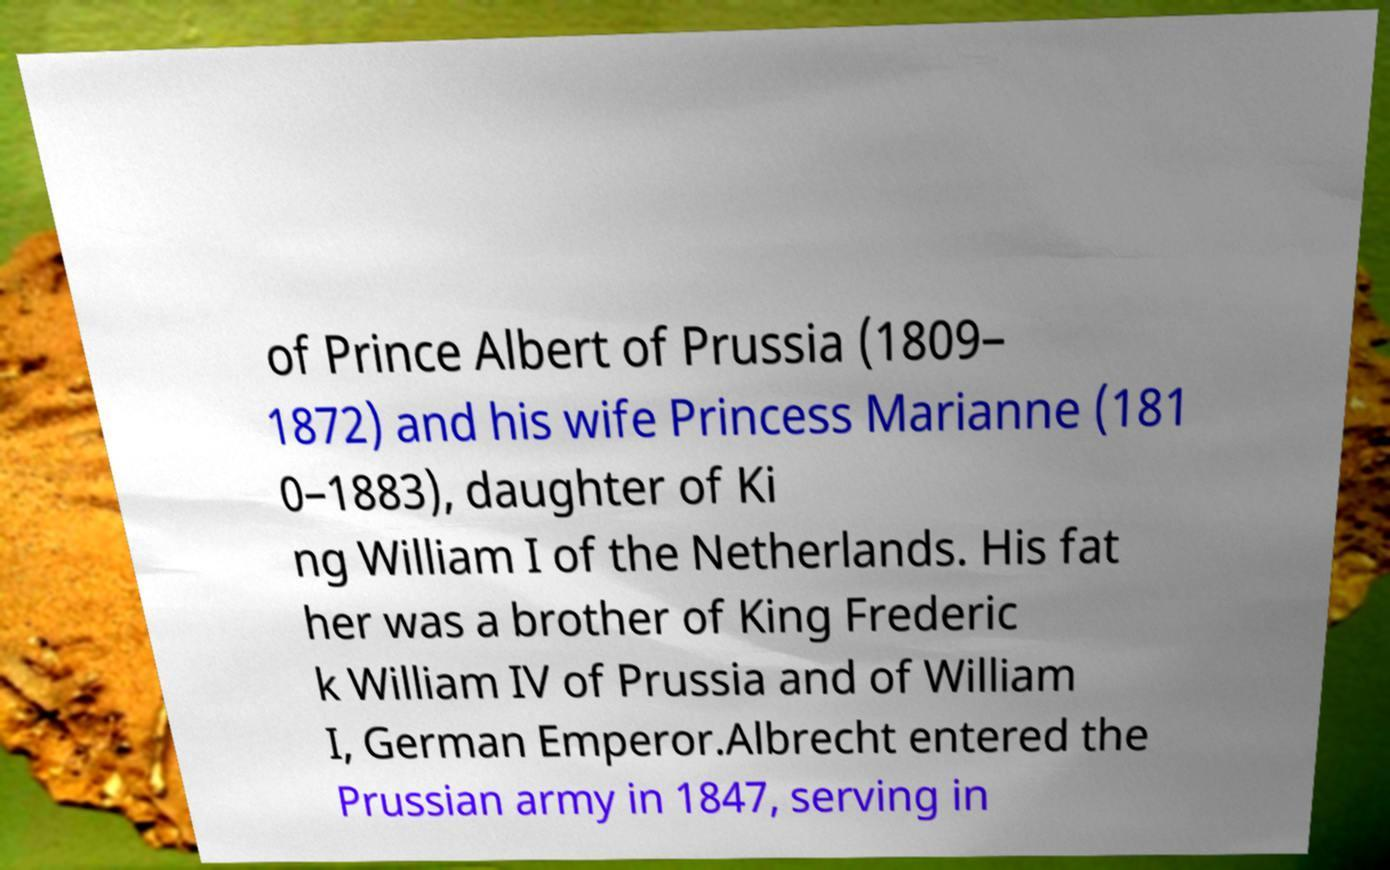There's text embedded in this image that I need extracted. Can you transcribe it verbatim? of Prince Albert of Prussia (1809– 1872) and his wife Princess Marianne (181 0–1883), daughter of Ki ng William I of the Netherlands. His fat her was a brother of King Frederic k William IV of Prussia and of William I, German Emperor.Albrecht entered the Prussian army in 1847, serving in 